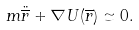Convert formula to latex. <formula><loc_0><loc_0><loc_500><loc_500>m \ddot { \overline { r } } + \nabla U ( \overline { r } ) \simeq 0 .</formula> 